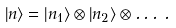<formula> <loc_0><loc_0><loc_500><loc_500>\left | n \right \rangle = \left | n _ { 1 } \right \rangle \otimes \left | n _ { 2 } \right \rangle \otimes \dots \, .</formula> 